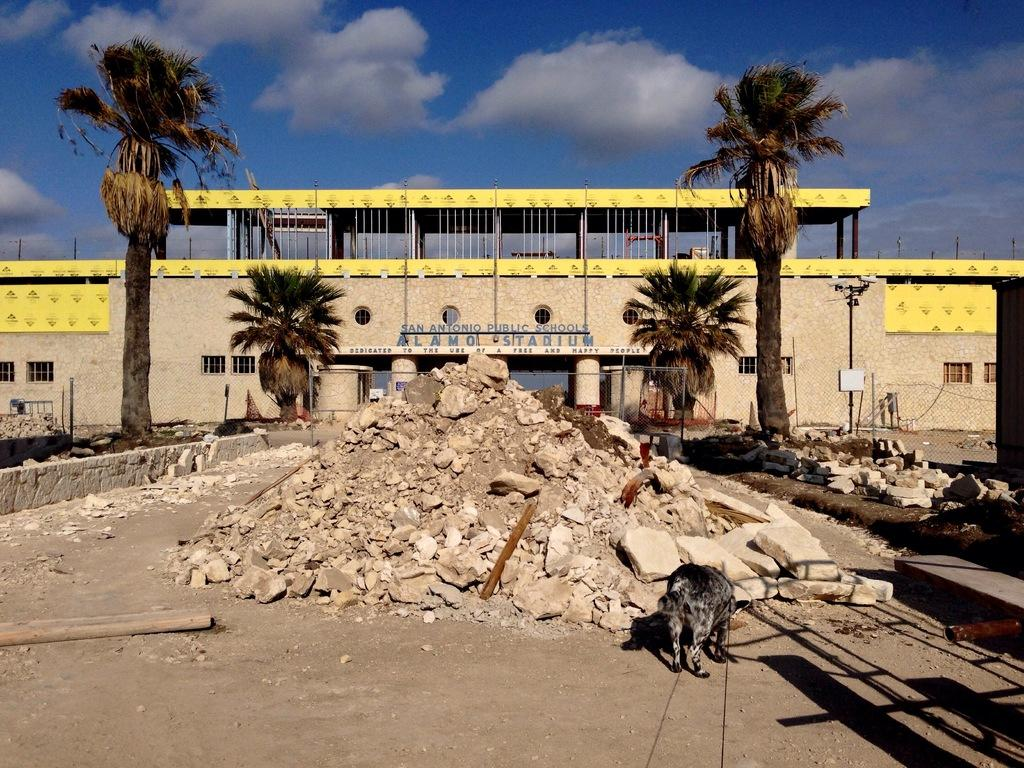What type of natural elements can be seen in the image? There are stones in the image. What type of man-made structure is present in the image? There is a building in the image. What additional man-made structure can be seen at the top of the image? There is a shed visible at the top of the image. How many trees are present in the image? There are two trees in the image. What is visible at the top of the image? The sky is visible at the top of the image. What type of cord is used to connect the trees in the image? There is no cord connecting the trees in the image; they are separate trees. 